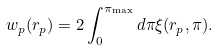Convert formula to latex. <formula><loc_0><loc_0><loc_500><loc_500>w _ { p } ( r _ { p } ) = 2 \int _ { 0 } ^ { \pi _ { \max } } d \pi \xi ( r _ { p } , \pi ) .</formula> 